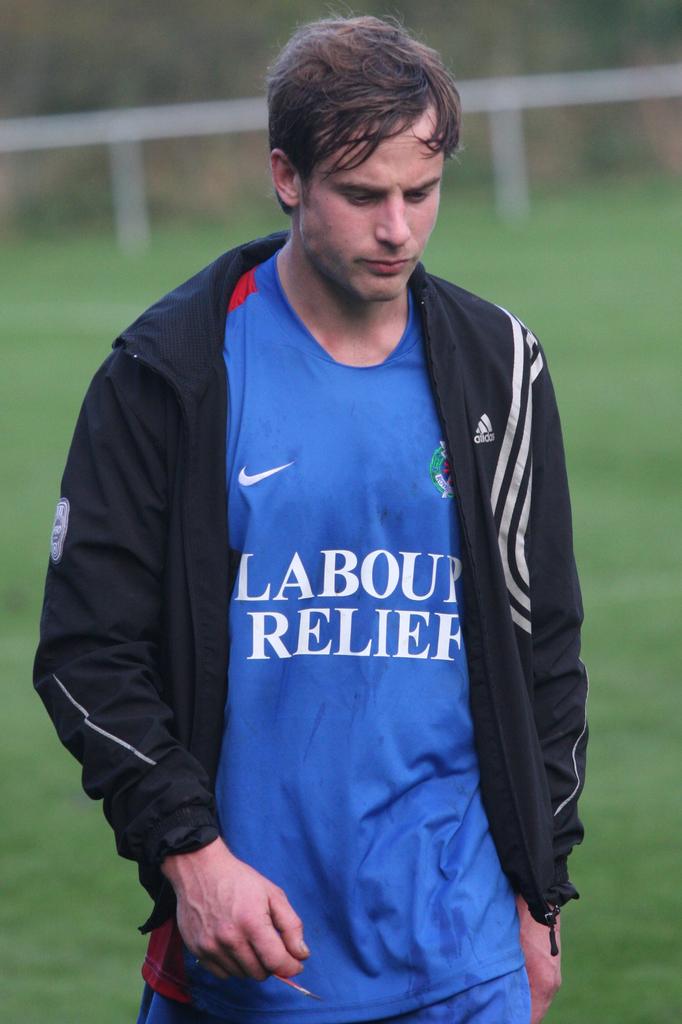What brand is on his jacket?
Offer a very short reply. Adidas. 